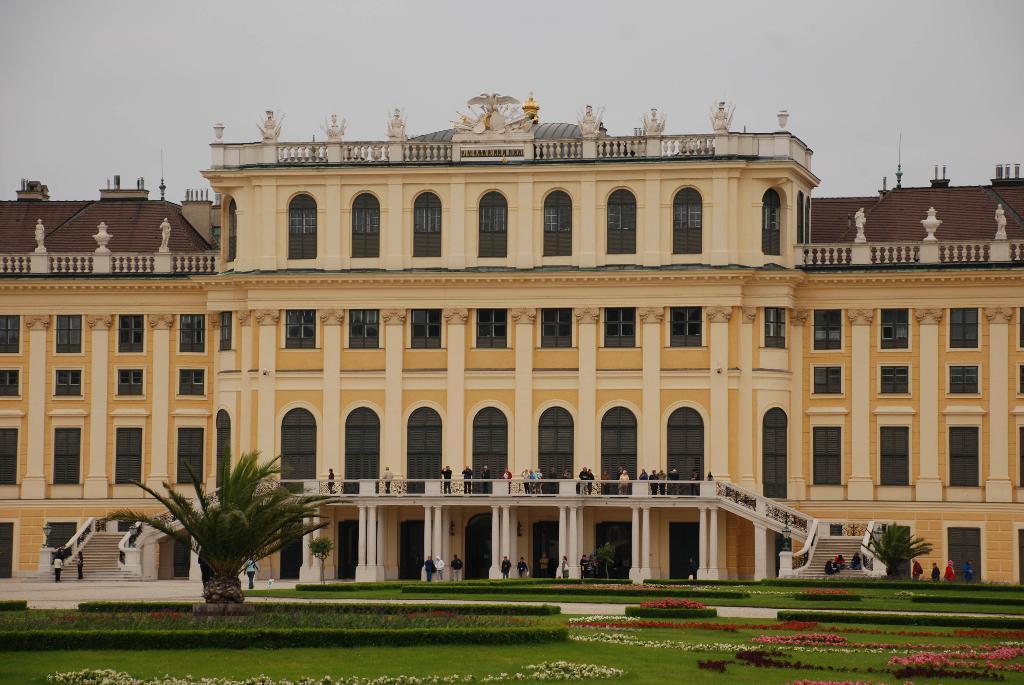Can you describe this image briefly? In this image I can see the grass. I can see the flowers and the trees. I can also some people. In the background, I can see the building and the sky. 